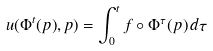Convert formula to latex. <formula><loc_0><loc_0><loc_500><loc_500>u ( \Phi ^ { t } ( p ) , p ) = \int _ { 0 } ^ { t } f \circ \Phi ^ { \tau } ( p ) \, d \tau</formula> 